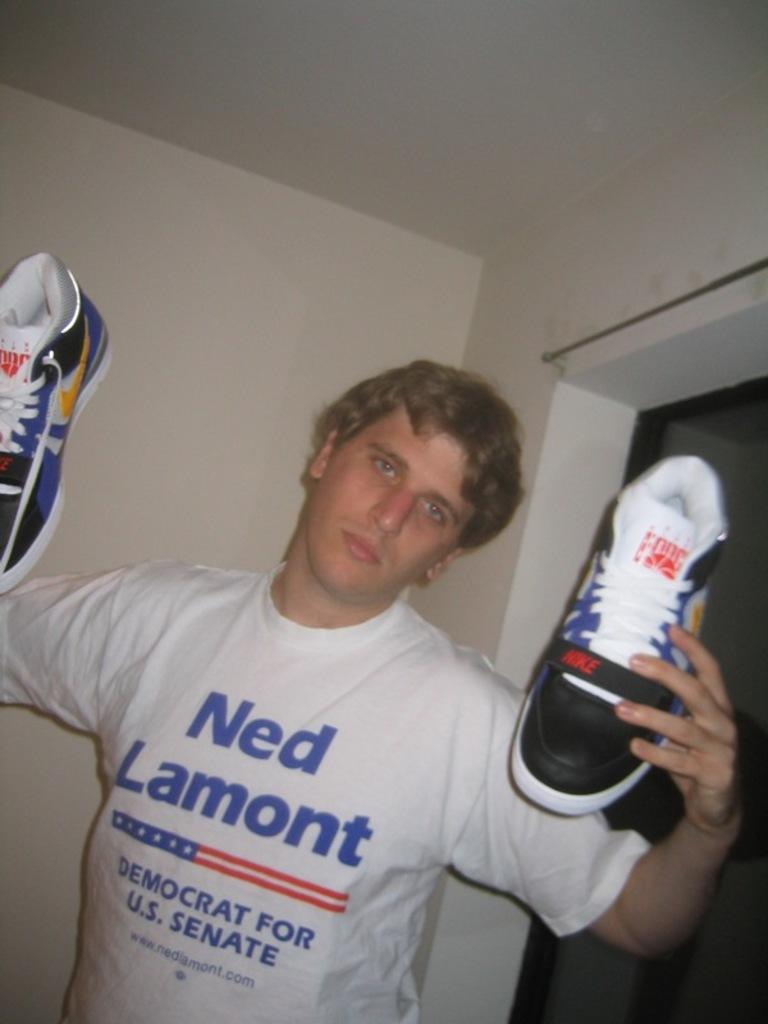<image>
Write a terse but informative summary of the picture. A boy in a Ned Lamont shirt holding a pair of shoes 